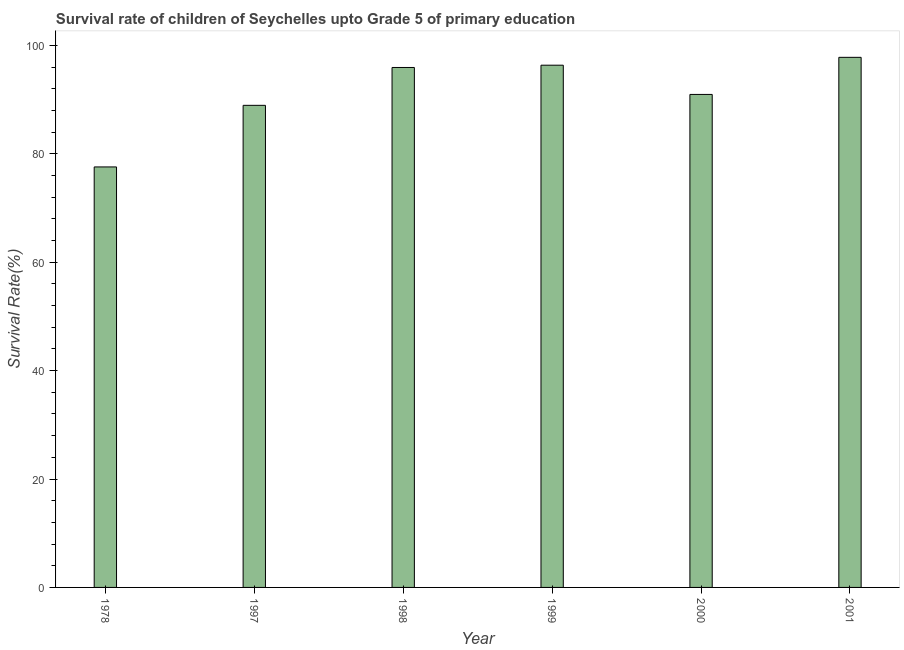What is the title of the graph?
Ensure brevity in your answer.  Survival rate of children of Seychelles upto Grade 5 of primary education. What is the label or title of the Y-axis?
Provide a short and direct response. Survival Rate(%). What is the survival rate in 1978?
Your response must be concise. 77.58. Across all years, what is the maximum survival rate?
Your response must be concise. 97.8. Across all years, what is the minimum survival rate?
Provide a succinct answer. 77.58. In which year was the survival rate maximum?
Offer a terse response. 2001. In which year was the survival rate minimum?
Offer a very short reply. 1978. What is the sum of the survival rate?
Ensure brevity in your answer.  547.54. What is the difference between the survival rate in 1997 and 2000?
Offer a terse response. -2.01. What is the average survival rate per year?
Offer a very short reply. 91.26. What is the median survival rate?
Your answer should be compact. 93.44. Do a majority of the years between 2000 and 2001 (inclusive) have survival rate greater than 84 %?
Make the answer very short. Yes. What is the ratio of the survival rate in 1978 to that in 1998?
Your answer should be compact. 0.81. Is the survival rate in 1978 less than that in 2000?
Ensure brevity in your answer.  Yes. What is the difference between the highest and the second highest survival rate?
Your response must be concise. 1.45. What is the difference between the highest and the lowest survival rate?
Your response must be concise. 20.22. In how many years, is the survival rate greater than the average survival rate taken over all years?
Keep it short and to the point. 3. How many years are there in the graph?
Your response must be concise. 6. What is the difference between two consecutive major ticks on the Y-axis?
Your answer should be very brief. 20. What is the Survival Rate(%) in 1978?
Provide a succinct answer. 77.58. What is the Survival Rate(%) of 1997?
Give a very brief answer. 88.94. What is the Survival Rate(%) in 1998?
Provide a succinct answer. 95.92. What is the Survival Rate(%) of 1999?
Provide a short and direct response. 96.35. What is the Survival Rate(%) of 2000?
Offer a terse response. 90.95. What is the Survival Rate(%) in 2001?
Offer a terse response. 97.8. What is the difference between the Survival Rate(%) in 1978 and 1997?
Your answer should be compact. -11.36. What is the difference between the Survival Rate(%) in 1978 and 1998?
Give a very brief answer. -18.35. What is the difference between the Survival Rate(%) in 1978 and 1999?
Your response must be concise. -18.77. What is the difference between the Survival Rate(%) in 1978 and 2000?
Your response must be concise. -13.38. What is the difference between the Survival Rate(%) in 1978 and 2001?
Ensure brevity in your answer.  -20.22. What is the difference between the Survival Rate(%) in 1997 and 1998?
Your answer should be very brief. -6.98. What is the difference between the Survival Rate(%) in 1997 and 1999?
Ensure brevity in your answer.  -7.4. What is the difference between the Survival Rate(%) in 1997 and 2000?
Make the answer very short. -2.01. What is the difference between the Survival Rate(%) in 1997 and 2001?
Provide a short and direct response. -8.86. What is the difference between the Survival Rate(%) in 1998 and 1999?
Provide a short and direct response. -0.42. What is the difference between the Survival Rate(%) in 1998 and 2000?
Your response must be concise. 4.97. What is the difference between the Survival Rate(%) in 1998 and 2001?
Make the answer very short. -1.87. What is the difference between the Survival Rate(%) in 1999 and 2000?
Offer a terse response. 5.39. What is the difference between the Survival Rate(%) in 1999 and 2001?
Offer a terse response. -1.45. What is the difference between the Survival Rate(%) in 2000 and 2001?
Provide a short and direct response. -6.84. What is the ratio of the Survival Rate(%) in 1978 to that in 1997?
Provide a short and direct response. 0.87. What is the ratio of the Survival Rate(%) in 1978 to that in 1998?
Ensure brevity in your answer.  0.81. What is the ratio of the Survival Rate(%) in 1978 to that in 1999?
Keep it short and to the point. 0.81. What is the ratio of the Survival Rate(%) in 1978 to that in 2000?
Offer a terse response. 0.85. What is the ratio of the Survival Rate(%) in 1978 to that in 2001?
Provide a succinct answer. 0.79. What is the ratio of the Survival Rate(%) in 1997 to that in 1998?
Ensure brevity in your answer.  0.93. What is the ratio of the Survival Rate(%) in 1997 to that in 1999?
Offer a terse response. 0.92. What is the ratio of the Survival Rate(%) in 1997 to that in 2001?
Offer a terse response. 0.91. What is the ratio of the Survival Rate(%) in 1998 to that in 1999?
Give a very brief answer. 1. What is the ratio of the Survival Rate(%) in 1998 to that in 2000?
Give a very brief answer. 1.05. What is the ratio of the Survival Rate(%) in 1998 to that in 2001?
Your answer should be very brief. 0.98. What is the ratio of the Survival Rate(%) in 1999 to that in 2000?
Offer a very short reply. 1.06. What is the ratio of the Survival Rate(%) in 2000 to that in 2001?
Give a very brief answer. 0.93. 